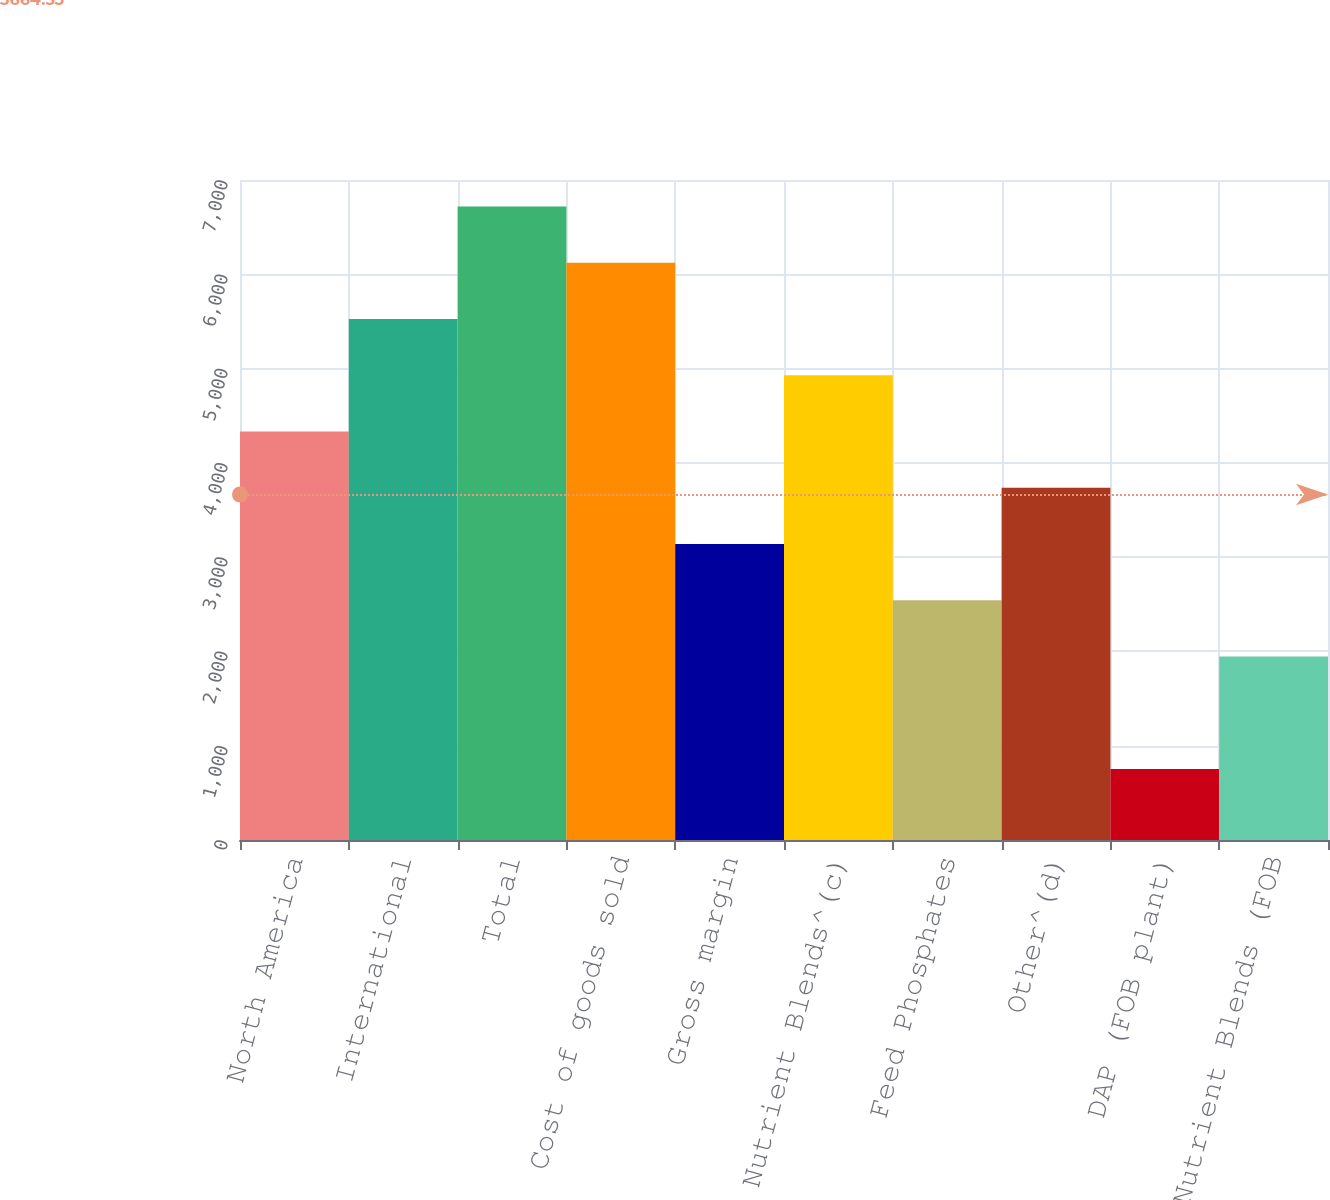Convert chart to OTSL. <chart><loc_0><loc_0><loc_500><loc_500><bar_chart><fcel>North America<fcel>International<fcel>Total<fcel>Cost of goods sold<fcel>Gross margin<fcel>Crop Nutrient Blends^(c)<fcel>Feed Phosphates<fcel>Other^(d)<fcel>DAP (FOB plant)<fcel>Crop Nutrient Blends (FOB<nl><fcel>4332.22<fcel>5525.14<fcel>6718.06<fcel>6121.6<fcel>3139.3<fcel>4928.68<fcel>2542.84<fcel>3735.76<fcel>753.46<fcel>1946.38<nl></chart> 